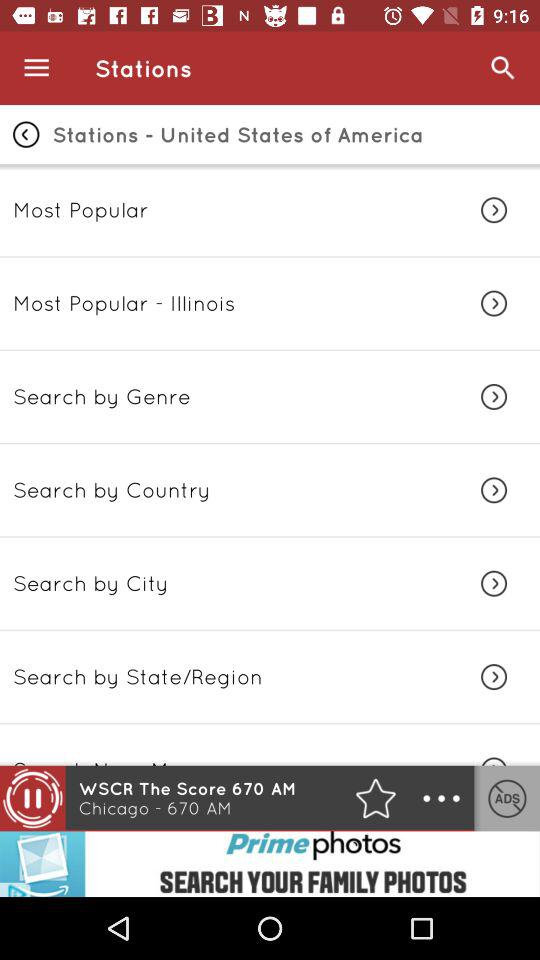What is the mentioned country? The mentioned country is the United States of America. 